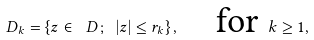<formula> <loc_0><loc_0><loc_500><loc_500>D _ { k } = \{ z \in \ D \, ; \ | z | \leq r _ { k } \} \, , \quad \text {for } k \geq 1 ,</formula> 